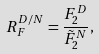<formula> <loc_0><loc_0><loc_500><loc_500>R _ { F } ^ { D / N } = \frac { F ^ { D } _ { 2 } } { \tilde { F } ^ { N } _ { 2 } } ,</formula> 